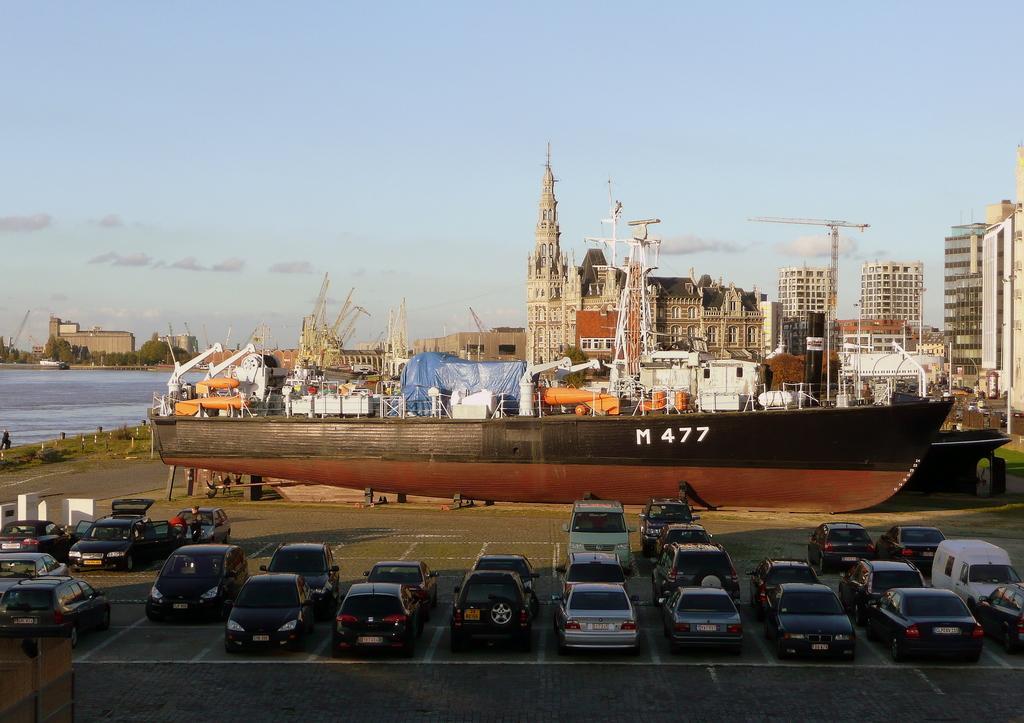Could you give a brief overview of what you see in this image? In this picture we can see vehicles on the ground, here we can see boats, buildings, poles, water, trees and some objects and we can see sky in the background. 